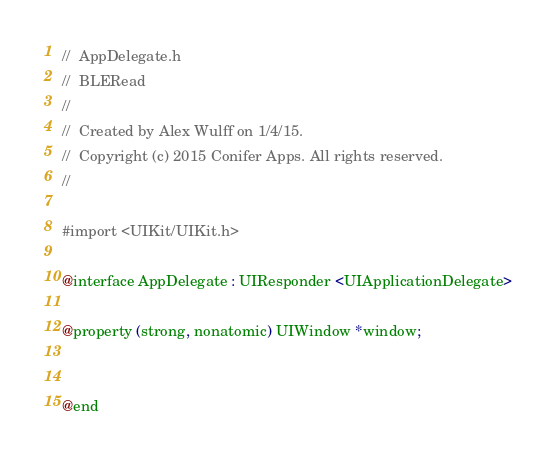<code> <loc_0><loc_0><loc_500><loc_500><_C_>//  AppDelegate.h
//  BLERead
//
//  Created by Alex Wulff on 1/4/15.
//  Copyright (c) 2015 Conifer Apps. All rights reserved.
//

#import <UIKit/UIKit.h>

@interface AppDelegate : UIResponder <UIApplicationDelegate>

@property (strong, nonatomic) UIWindow *window;


@end

</code> 